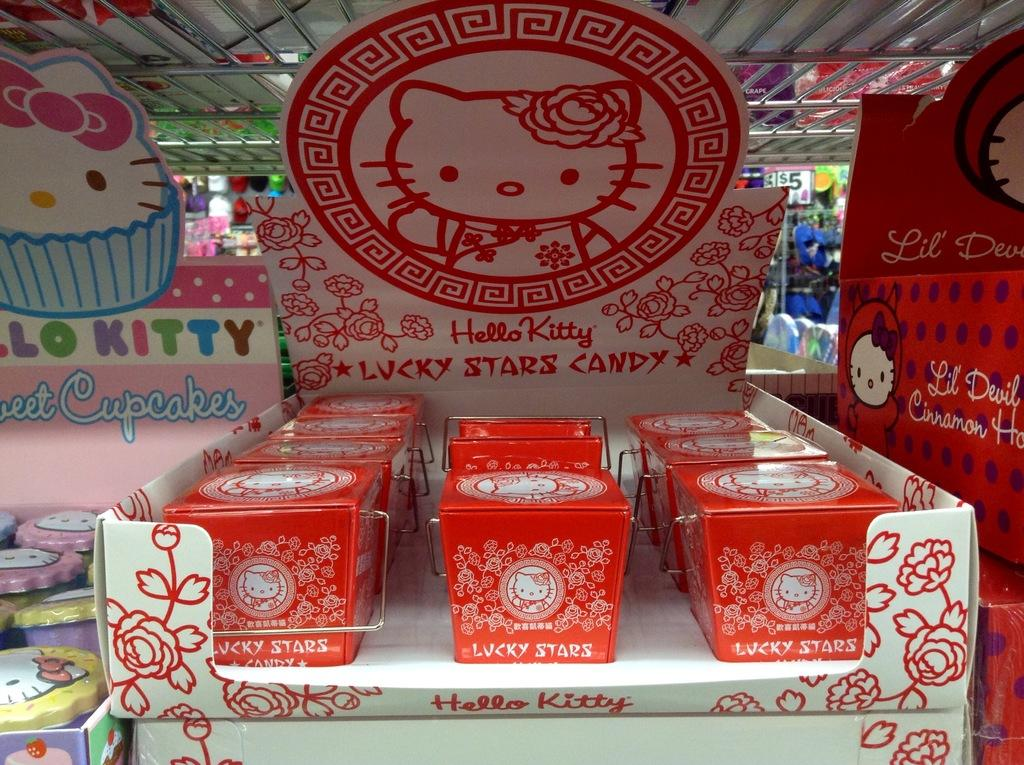What type of objects are featured in the image? There are boxes with designs in the image. Can you describe the appearance of the boxes? The boxes have designs and writing on them. What is the relationship between the larger and smaller boxes in the image? The smaller boxes are inside the larger boxes. Do the smaller boxes also have designs and writing? Yes, the smaller boxes also have designs and writing on them. How does the mask help the boxes in the image? There is no mask present in the image, so it cannot help the boxes. 